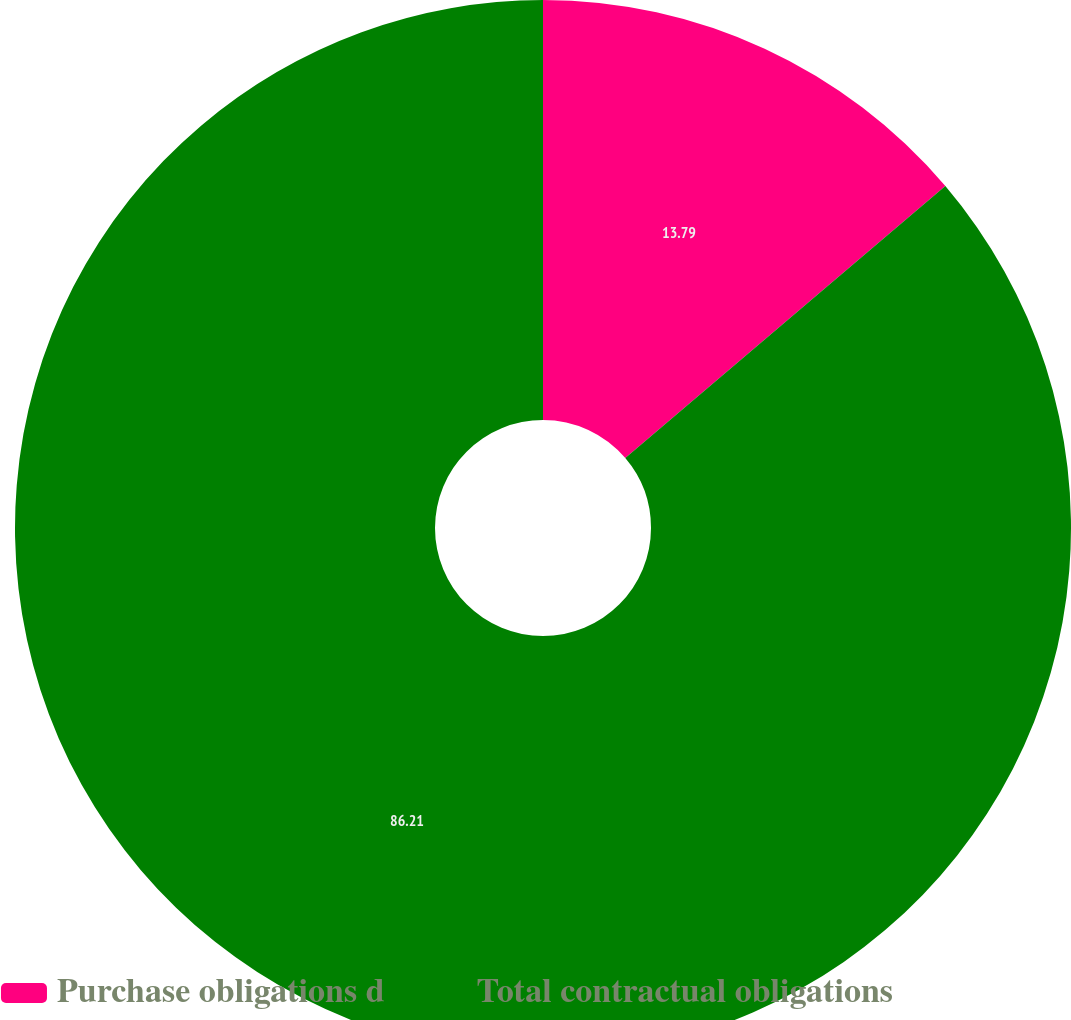<chart> <loc_0><loc_0><loc_500><loc_500><pie_chart><fcel>Purchase obligations d<fcel>Total contractual obligations<nl><fcel>13.79%<fcel>86.21%<nl></chart> 